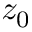<formula> <loc_0><loc_0><loc_500><loc_500>z _ { 0 }</formula> 